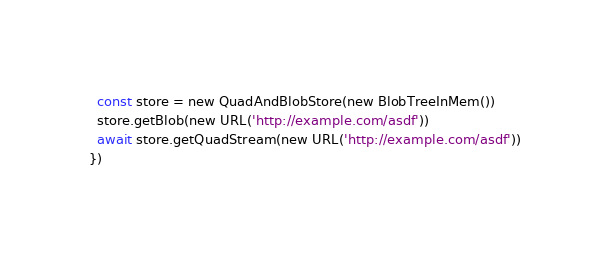Convert code to text. <code><loc_0><loc_0><loc_500><loc_500><_TypeScript_>  const store = new QuadAndBlobStore(new BlobTreeInMem())
  store.getBlob(new URL('http://example.com/asdf'))
  await store.getQuadStream(new URL('http://example.com/asdf'))
})
</code> 